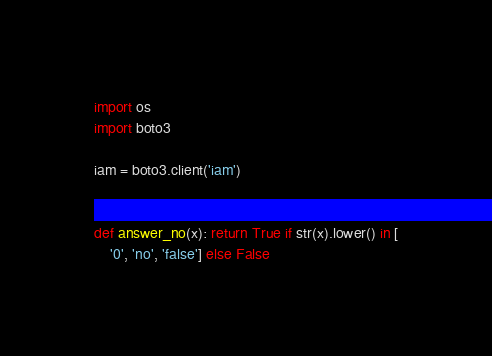Convert code to text. <code><loc_0><loc_0><loc_500><loc_500><_Python_>import os
import boto3

iam = boto3.client('iam')


def answer_no(x): return True if str(x).lower() in [
    '0', 'no', 'false'] else False

</code> 